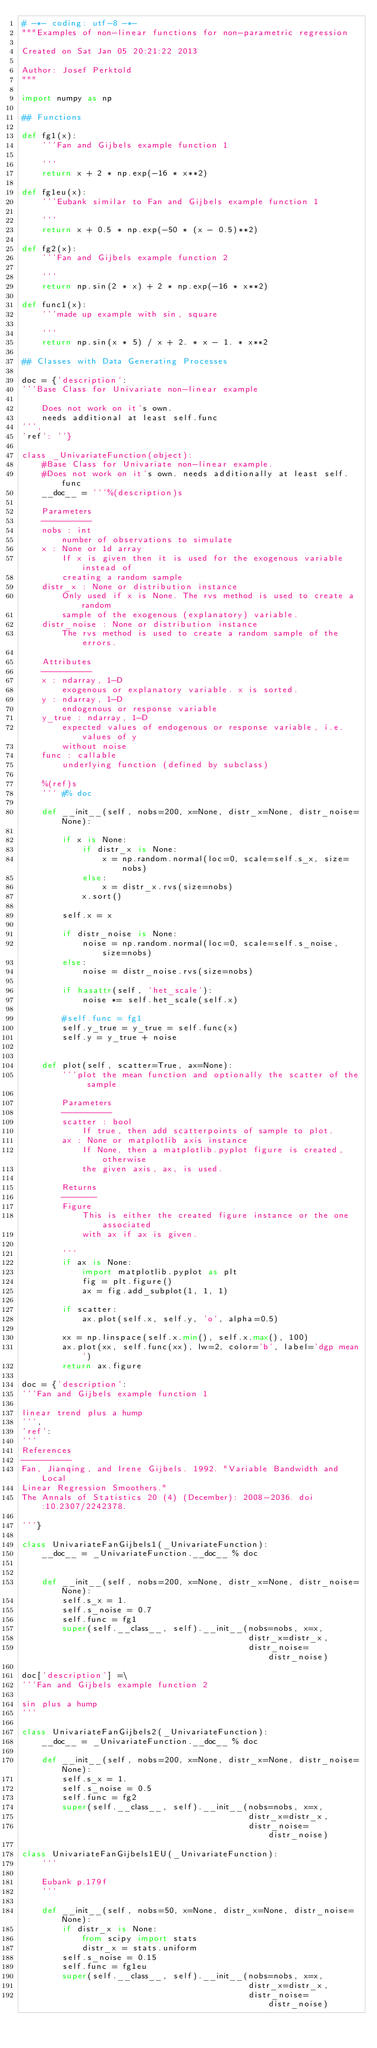<code> <loc_0><loc_0><loc_500><loc_500><_Python_># -*- coding: utf-8 -*-
"""Examples of non-linear functions for non-parametric regression

Created on Sat Jan 05 20:21:22 2013

Author: Josef Perktold
"""

import numpy as np

## Functions

def fg1(x):
    '''Fan and Gijbels example function 1

    '''
    return x + 2 * np.exp(-16 * x**2)

def fg1eu(x):
    '''Eubank similar to Fan and Gijbels example function 1

    '''
    return x + 0.5 * np.exp(-50 * (x - 0.5)**2)

def fg2(x):
    '''Fan and Gijbels example function 2

    '''
    return np.sin(2 * x) + 2 * np.exp(-16 * x**2)

def func1(x):
    '''made up example with sin, square

    '''
    return np.sin(x * 5) / x + 2. * x - 1. * x**2

## Classes with Data Generating Processes

doc = {'description':
'''Base Class for Univariate non-linear example

    Does not work on it's own.
    needs additional at least self.func
''',
'ref': ''}

class _UnivariateFunction(object):
    #Base Class for Univariate non-linear example.
    #Does not work on it's own. needs additionally at least self.func
    __doc__ = '''%(description)s

    Parameters
    ----------
    nobs : int
        number of observations to simulate
    x : None or 1d array
        If x is given then it is used for the exogenous variable instead of
        creating a random sample
    distr_x : None or distribution instance
        Only used if x is None. The rvs method is used to create a random
        sample of the exogenous (explanatory) variable.
    distr_noise : None or distribution instance
        The rvs method is used to create a random sample of the errors.

    Attributes
    ----------
    x : ndarray, 1-D
        exogenous or explanatory variable. x is sorted.
    y : ndarray, 1-D
        endogenous or response variable
    y_true : ndarray, 1-D
        expected values of endogenous or response variable, i.e. values of y
        without noise
    func : callable
        underlying function (defined by subclass)

    %(ref)s
    ''' #% doc

    def __init__(self, nobs=200, x=None, distr_x=None, distr_noise=None):

        if x is None:
            if distr_x is None:
                x = np.random.normal(loc=0, scale=self.s_x, size=nobs)
            else:
                x = distr_x.rvs(size=nobs)
            x.sort()

        self.x = x

        if distr_noise is None:
            noise = np.random.normal(loc=0, scale=self.s_noise, size=nobs)
        else:
            noise = distr_noise.rvs(size=nobs)

        if hasattr(self, 'het_scale'):
            noise *= self.het_scale(self.x)

        #self.func = fg1
        self.y_true = y_true = self.func(x)
        self.y = y_true + noise


    def plot(self, scatter=True, ax=None):
        '''plot the mean function and optionally the scatter of the sample

        Parameters
        ----------
        scatter : bool
            If true, then add scatterpoints of sample to plot.
        ax : None or matplotlib axis instance
            If None, then a matplotlib.pyplot figure is created, otherwise
            the given axis, ax, is used.

        Returns
        -------
        Figure
            This is either the created figure instance or the one associated
            with ax if ax is given.

        '''
        if ax is None:
            import matplotlib.pyplot as plt
            fig = plt.figure()
            ax = fig.add_subplot(1, 1, 1)

        if scatter:
            ax.plot(self.x, self.y, 'o', alpha=0.5)

        xx = np.linspace(self.x.min(), self.x.max(), 100)
        ax.plot(xx, self.func(xx), lw=2, color='b', label='dgp mean')
        return ax.figure

doc = {'description':
'''Fan and Gijbels example function 1

linear trend plus a hump
''',
'ref':
'''
References
----------
Fan, Jianqing, and Irene Gijbels. 1992. "Variable Bandwidth and Local
Linear Regression Smoothers."
The Annals of Statistics 20 (4) (December): 2008-2036. doi:10.2307/2242378.

'''}

class UnivariateFanGijbels1(_UnivariateFunction):
    __doc__ = _UnivariateFunction.__doc__ % doc


    def __init__(self, nobs=200, x=None, distr_x=None, distr_noise=None):
        self.s_x = 1.
        self.s_noise = 0.7
        self.func = fg1
        super(self.__class__, self).__init__(nobs=nobs, x=x,
                                             distr_x=distr_x,
                                             distr_noise=distr_noise)

doc['description'] =\
'''Fan and Gijbels example function 2

sin plus a hump
'''

class UnivariateFanGijbels2(_UnivariateFunction):
    __doc__ = _UnivariateFunction.__doc__ % doc

    def __init__(self, nobs=200, x=None, distr_x=None, distr_noise=None):
        self.s_x = 1.
        self.s_noise = 0.5
        self.func = fg2
        super(self.__class__, self).__init__(nobs=nobs, x=x,
                                             distr_x=distr_x,
                                             distr_noise=distr_noise)

class UnivariateFanGijbels1EU(_UnivariateFunction):
    '''

    Eubank p.179f
    '''

    def __init__(self, nobs=50, x=None, distr_x=None, distr_noise=None):
        if distr_x is None:
            from scipy import stats
            distr_x = stats.uniform
        self.s_noise = 0.15
        self.func = fg1eu
        super(self.__class__, self).__init__(nobs=nobs, x=x,
                                             distr_x=distr_x,
                                             distr_noise=distr_noise)
</code> 